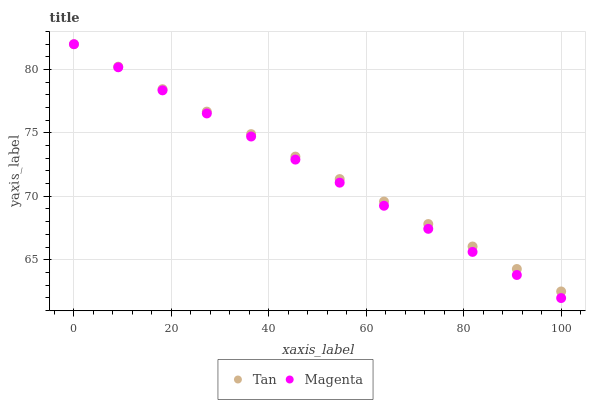Does Magenta have the minimum area under the curve?
Answer yes or no. Yes. Does Tan have the maximum area under the curve?
Answer yes or no. Yes. Does Magenta have the maximum area under the curve?
Answer yes or no. No. Is Tan the smoothest?
Answer yes or no. Yes. Is Magenta the roughest?
Answer yes or no. Yes. Is Magenta the smoothest?
Answer yes or no. No. Does Magenta have the lowest value?
Answer yes or no. Yes. Does Magenta have the highest value?
Answer yes or no. Yes. Does Tan intersect Magenta?
Answer yes or no. Yes. Is Tan less than Magenta?
Answer yes or no. No. Is Tan greater than Magenta?
Answer yes or no. No. 